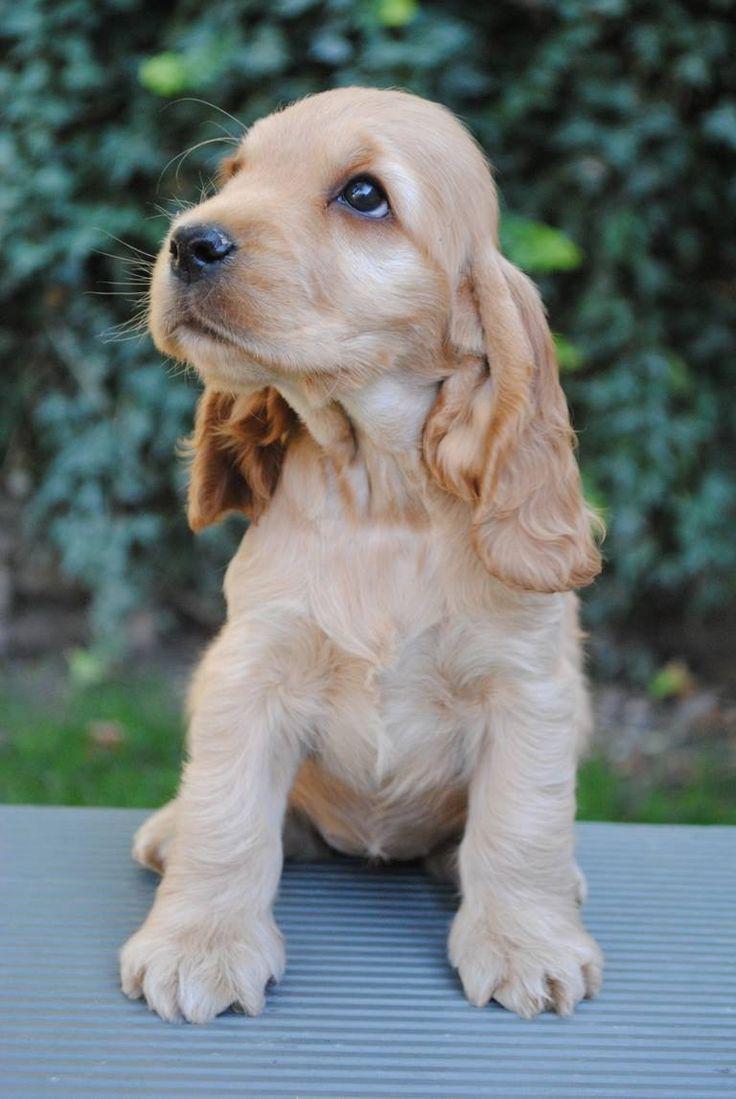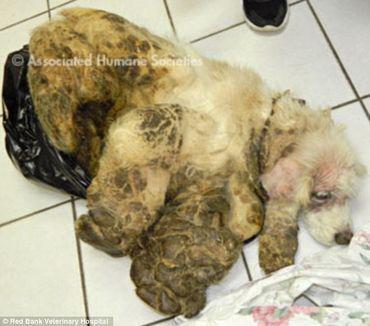The first image is the image on the left, the second image is the image on the right. For the images shown, is this caption "The dog in the image on the right is being held up outside." true? Answer yes or no. No. The first image is the image on the left, the second image is the image on the right. Examine the images to the left and right. Is the description "There are two dogs with black fur and floppy ears." accurate? Answer yes or no. No. 